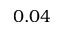Convert formula to latex. <formula><loc_0><loc_0><loc_500><loc_500>0 . 0 4</formula> 